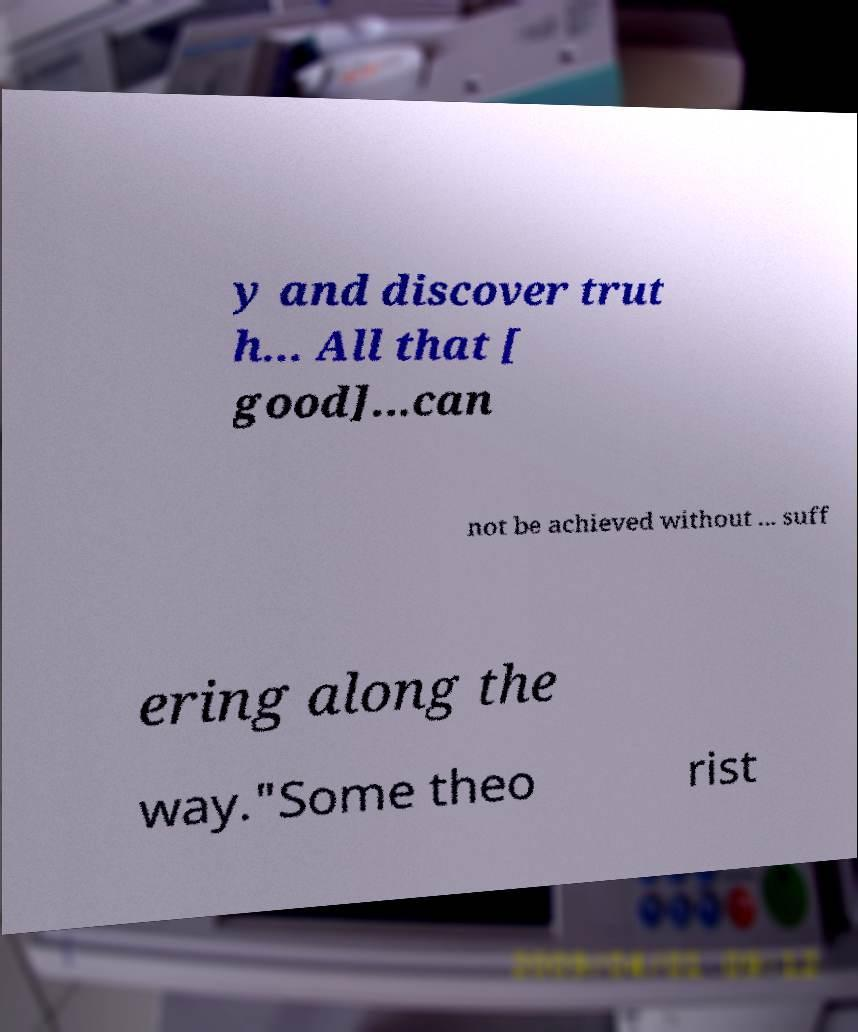Can you accurately transcribe the text from the provided image for me? y and discover trut h... All that [ good]...can not be achieved without ... suff ering along the way."Some theo rist 